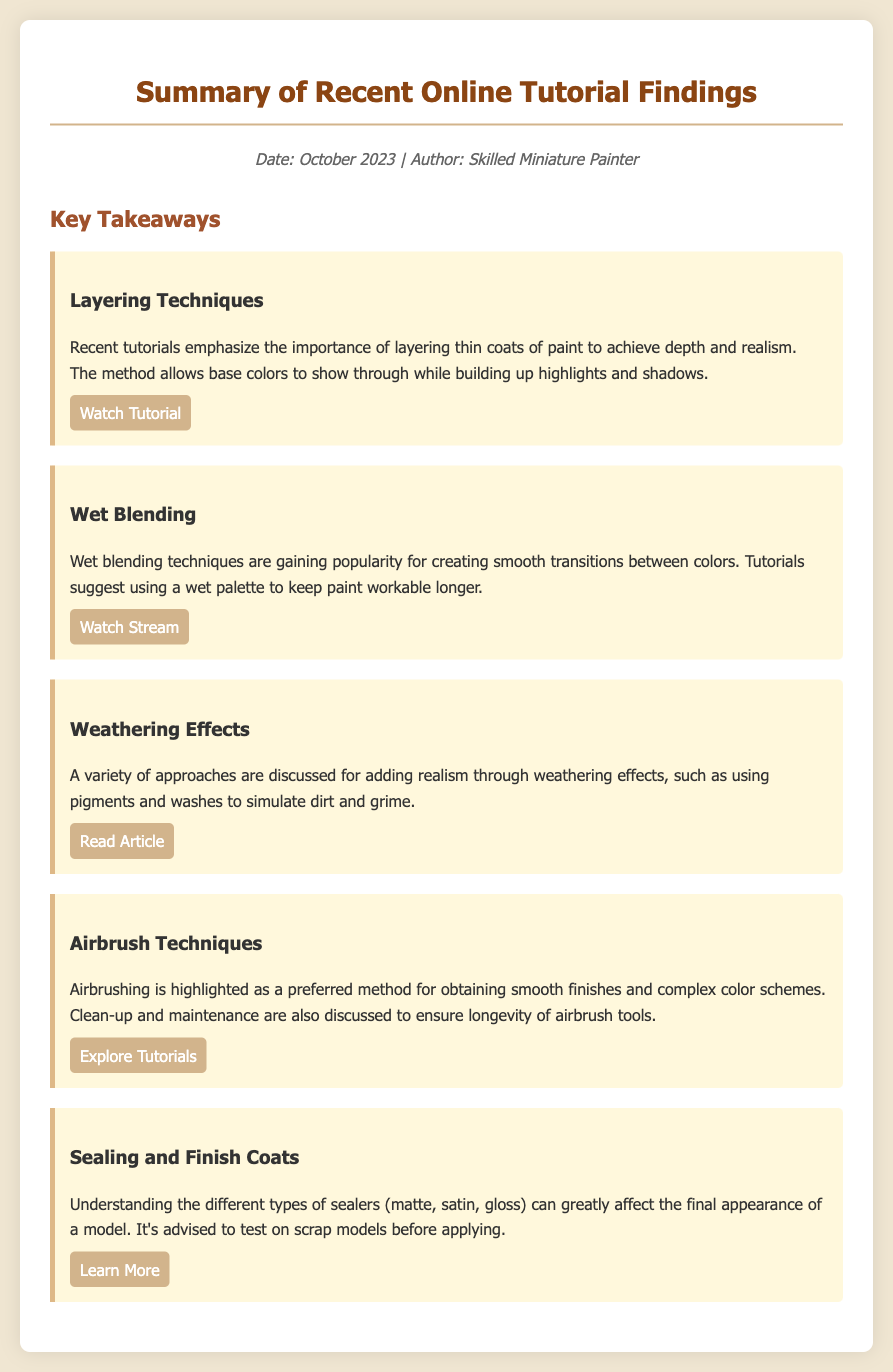What is the main focus of the tutorials? The tutorials focus on various techniques and tips to improve miniature painting, including layering, wet blending, and weathering effects.
Answer: Techniques and tips When was the memo written? The date mentioned in the memo indicates when the findings were summarized.
Answer: October 2023 What technique emphasizes using thin coats of paint? The memo includes specific techniques that highlight the use of layering for achieving depth and realism.
Answer: Layering Techniques How can smooth transitions between colors be achieved? The document suggests that wet blending techniques are effective for creating smooth color transitions.
Answer: Wet Blending What is recommended for maintaining airbrush tools? The memo mentions that clean-up and maintenance are essential to ensuring tool longevity, but lacks specific details on methods.
Answer: Clean-up and maintenance Which type of finish is affected by the choice of sealer? The memo highlights how different sealer types can greatly impact the final appearance of a model.
Answer: Final appearance What resource is linked to learn about weathering effects? The document provides specific links for resources concerning various techniques, including weathering effects.
Answer: Read Article What is a preferred method for obtaining smooth finishes? The memo states that airbrushing is highlighted as a method for obtaining smooth finishes and intricate color schemes.
Answer: Airbrush Techniques 